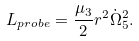<formula> <loc_0><loc_0><loc_500><loc_500>L _ { p r o b e } = { \frac { \mu _ { 3 } } { 2 } } r ^ { 2 } \dot { \Omega } _ { 5 } ^ { 2 } .</formula> 